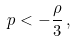Convert formula to latex. <formula><loc_0><loc_0><loc_500><loc_500>p < - \frac { \rho } { 3 } \, ,</formula> 